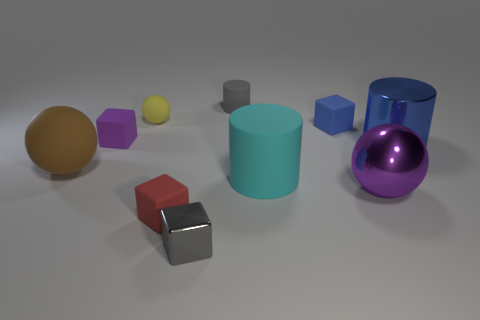Subtract all cylinders. How many objects are left? 7 Add 1 tiny blue shiny cylinders. How many tiny blue shiny cylinders exist? 1 Subtract 0 brown cubes. How many objects are left? 10 Subtract all metallic cylinders. Subtract all tiny gray cubes. How many objects are left? 8 Add 2 tiny gray cubes. How many tiny gray cubes are left? 3 